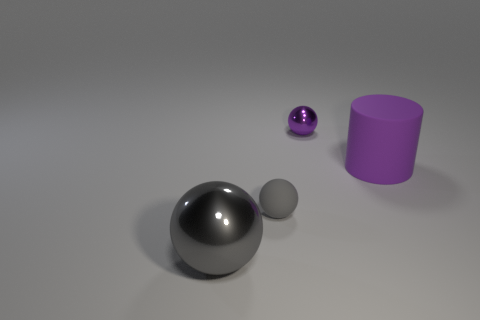Subtract all blue cubes. How many gray spheres are left? 2 Subtract all gray balls. How many balls are left? 1 Add 2 red cylinders. How many objects exist? 6 Subtract all cylinders. How many objects are left? 3 Subtract all tiny green metal blocks. Subtract all purple spheres. How many objects are left? 3 Add 3 purple rubber cylinders. How many purple rubber cylinders are left? 4 Add 2 big yellow rubber cylinders. How many big yellow rubber cylinders exist? 2 Subtract 0 blue cylinders. How many objects are left? 4 